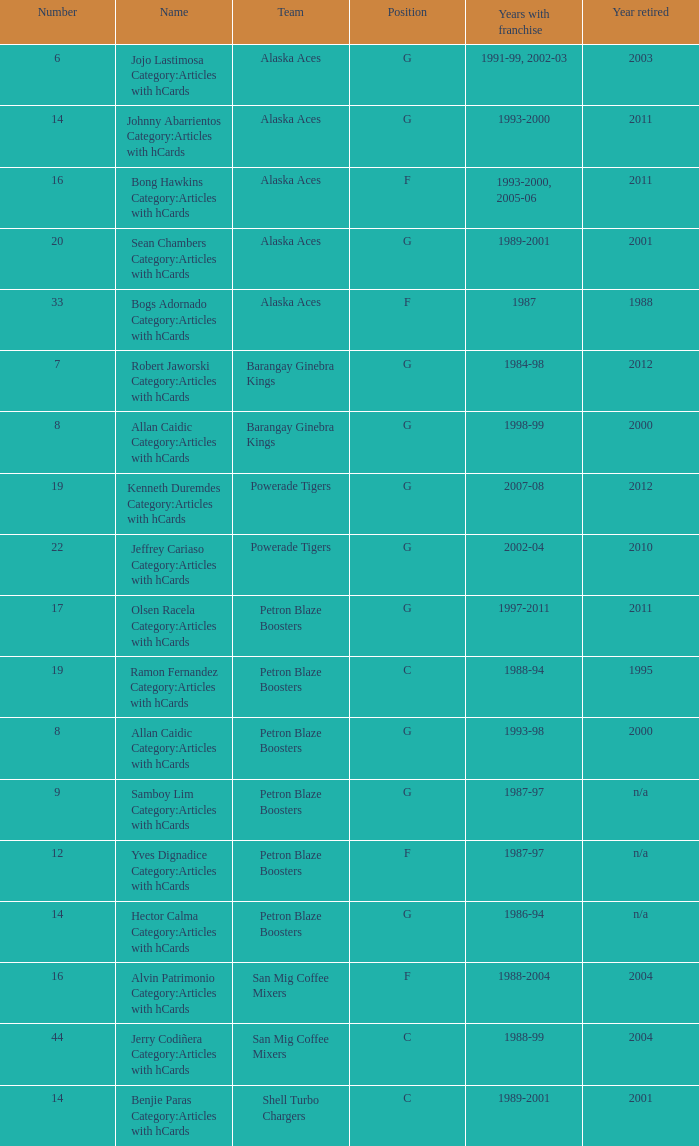For how many years did the team in slot 9 hold a franchise? 1987-97. 